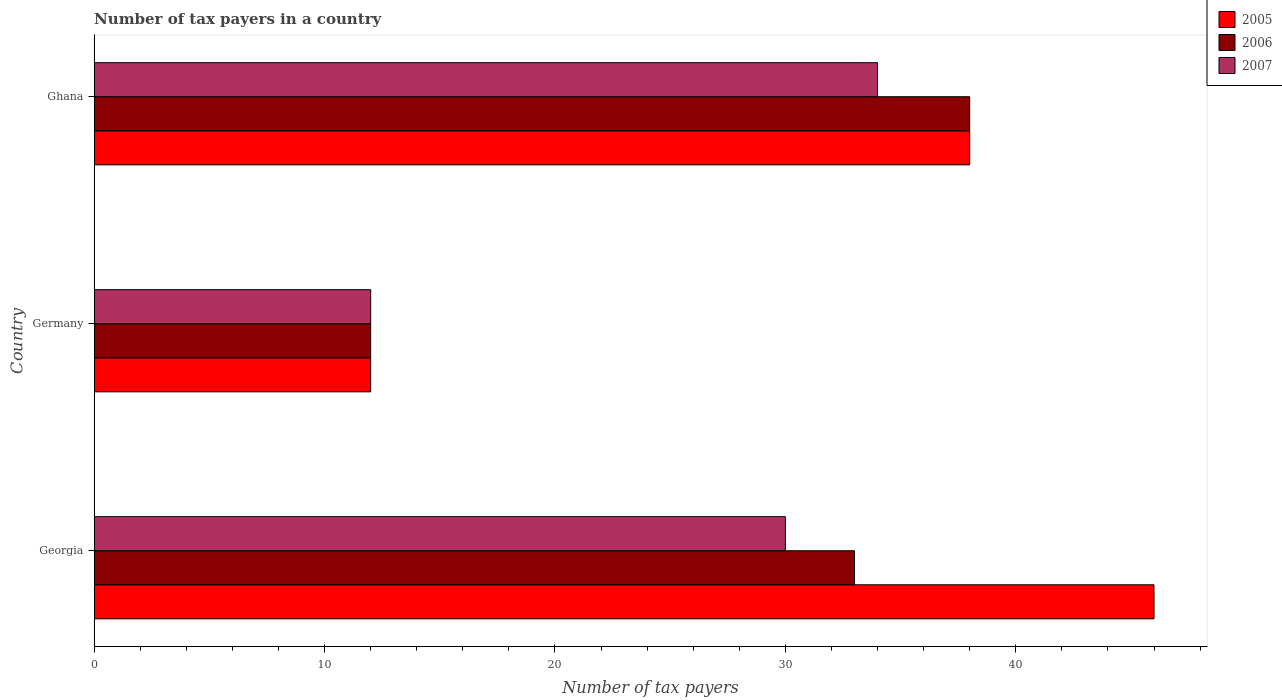How many different coloured bars are there?
Your answer should be compact. 3. What is the label of the 3rd group of bars from the top?
Give a very brief answer. Georgia. Across all countries, what is the maximum number of tax payers in in 2006?
Offer a very short reply. 38. Across all countries, what is the minimum number of tax payers in in 2006?
Give a very brief answer. 12. What is the total number of tax payers in in 2005 in the graph?
Ensure brevity in your answer.  96. What is the average number of tax payers in in 2007 per country?
Offer a very short reply. 25.33. What is the ratio of the number of tax payers in in 2007 in Germany to that in Ghana?
Provide a short and direct response. 0.35. What is the difference between the highest and the second highest number of tax payers in in 2007?
Make the answer very short. 4. Is the sum of the number of tax payers in in 2007 in Georgia and Germany greater than the maximum number of tax payers in in 2005 across all countries?
Offer a very short reply. No. What does the 1st bar from the top in Georgia represents?
Provide a succinct answer. 2007. What does the 2nd bar from the bottom in Ghana represents?
Your answer should be very brief. 2006. Is it the case that in every country, the sum of the number of tax payers in in 2007 and number of tax payers in in 2006 is greater than the number of tax payers in in 2005?
Your answer should be compact. Yes. How many bars are there?
Provide a succinct answer. 9. How many countries are there in the graph?
Your response must be concise. 3. Are the values on the major ticks of X-axis written in scientific E-notation?
Provide a short and direct response. No. Does the graph contain any zero values?
Give a very brief answer. No. Does the graph contain grids?
Offer a terse response. No. How many legend labels are there?
Your answer should be very brief. 3. What is the title of the graph?
Provide a succinct answer. Number of tax payers in a country. Does "2007" appear as one of the legend labels in the graph?
Keep it short and to the point. Yes. What is the label or title of the X-axis?
Keep it short and to the point. Number of tax payers. What is the label or title of the Y-axis?
Keep it short and to the point. Country. What is the Number of tax payers in 2006 in Georgia?
Provide a short and direct response. 33. What is the Number of tax payers of 2007 in Georgia?
Keep it short and to the point. 30. What is the Number of tax payers in 2005 in Germany?
Offer a terse response. 12. What is the Number of tax payers of 2006 in Germany?
Make the answer very short. 12. What is the Number of tax payers of 2007 in Germany?
Your answer should be compact. 12. What is the Number of tax payers in 2005 in Ghana?
Offer a terse response. 38. What is the Number of tax payers in 2006 in Ghana?
Provide a short and direct response. 38. What is the Number of tax payers in 2007 in Ghana?
Your answer should be very brief. 34. Across all countries, what is the maximum Number of tax payers of 2005?
Provide a succinct answer. 46. Across all countries, what is the maximum Number of tax payers of 2007?
Your answer should be very brief. 34. Across all countries, what is the minimum Number of tax payers of 2005?
Your response must be concise. 12. What is the total Number of tax payers in 2005 in the graph?
Provide a succinct answer. 96. What is the total Number of tax payers in 2006 in the graph?
Your answer should be very brief. 83. What is the total Number of tax payers in 2007 in the graph?
Offer a very short reply. 76. What is the difference between the Number of tax payers in 2006 in Georgia and that in Germany?
Provide a succinct answer. 21. What is the difference between the Number of tax payers of 2007 in Georgia and that in Germany?
Offer a very short reply. 18. What is the difference between the Number of tax payers of 2005 in Georgia and that in Ghana?
Keep it short and to the point. 8. What is the difference between the Number of tax payers of 2007 in Georgia and that in Ghana?
Provide a succinct answer. -4. What is the difference between the Number of tax payers of 2006 in Germany and that in Ghana?
Keep it short and to the point. -26. What is the difference between the Number of tax payers of 2007 in Germany and that in Ghana?
Offer a terse response. -22. What is the difference between the Number of tax payers of 2005 in Georgia and the Number of tax payers of 2006 in Germany?
Your answer should be compact. 34. What is the difference between the Number of tax payers in 2006 in Georgia and the Number of tax payers in 2007 in Germany?
Give a very brief answer. 21. What is the difference between the Number of tax payers of 2005 in Georgia and the Number of tax payers of 2007 in Ghana?
Your answer should be very brief. 12. What is the difference between the Number of tax payers in 2006 in Georgia and the Number of tax payers in 2007 in Ghana?
Make the answer very short. -1. What is the difference between the Number of tax payers of 2005 in Germany and the Number of tax payers of 2006 in Ghana?
Offer a very short reply. -26. What is the difference between the Number of tax payers in 2005 in Germany and the Number of tax payers in 2007 in Ghana?
Make the answer very short. -22. What is the average Number of tax payers of 2006 per country?
Your response must be concise. 27.67. What is the average Number of tax payers in 2007 per country?
Offer a terse response. 25.33. What is the difference between the Number of tax payers in 2005 and Number of tax payers in 2007 in Georgia?
Give a very brief answer. 16. What is the difference between the Number of tax payers in 2005 and Number of tax payers in 2006 in Germany?
Provide a short and direct response. 0. What is the difference between the Number of tax payers of 2005 and Number of tax payers of 2006 in Ghana?
Ensure brevity in your answer.  0. What is the difference between the Number of tax payers in 2005 and Number of tax payers in 2007 in Ghana?
Provide a succinct answer. 4. What is the ratio of the Number of tax payers in 2005 in Georgia to that in Germany?
Your answer should be compact. 3.83. What is the ratio of the Number of tax payers of 2006 in Georgia to that in Germany?
Make the answer very short. 2.75. What is the ratio of the Number of tax payers in 2005 in Georgia to that in Ghana?
Provide a short and direct response. 1.21. What is the ratio of the Number of tax payers of 2006 in Georgia to that in Ghana?
Give a very brief answer. 0.87. What is the ratio of the Number of tax payers of 2007 in Georgia to that in Ghana?
Make the answer very short. 0.88. What is the ratio of the Number of tax payers in 2005 in Germany to that in Ghana?
Your answer should be compact. 0.32. What is the ratio of the Number of tax payers in 2006 in Germany to that in Ghana?
Offer a terse response. 0.32. What is the ratio of the Number of tax payers in 2007 in Germany to that in Ghana?
Give a very brief answer. 0.35. What is the difference between the highest and the lowest Number of tax payers of 2005?
Your answer should be very brief. 34. 